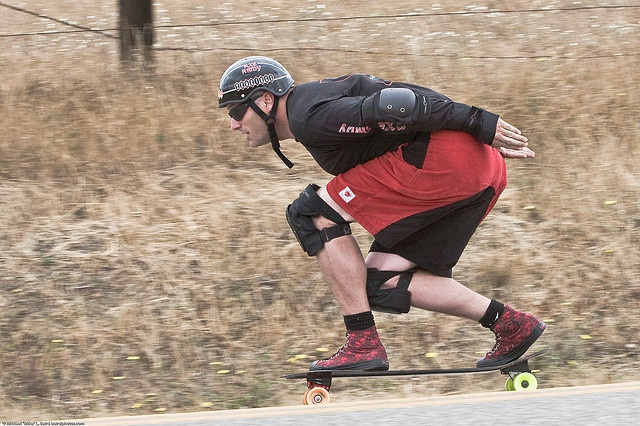Describe the objects in this image and their specific colors. I can see people in tan, black, gray, brown, and lightpink tones and skateboard in lightgray, gray, black, beige, and darkgray tones in this image. 